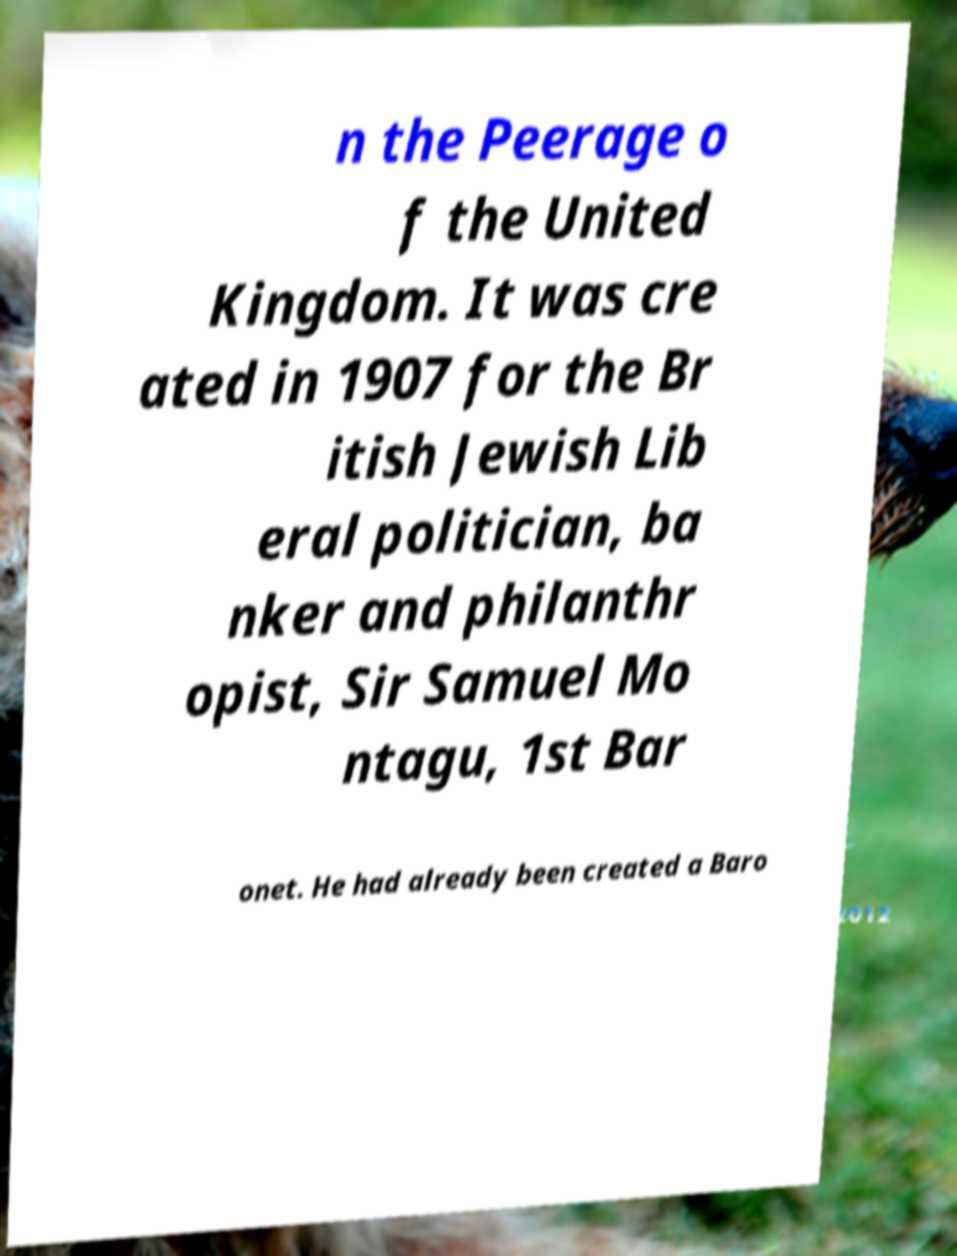There's text embedded in this image that I need extracted. Can you transcribe it verbatim? n the Peerage o f the United Kingdom. It was cre ated in 1907 for the Br itish Jewish Lib eral politician, ba nker and philanthr opist, Sir Samuel Mo ntagu, 1st Bar onet. He had already been created a Baro 